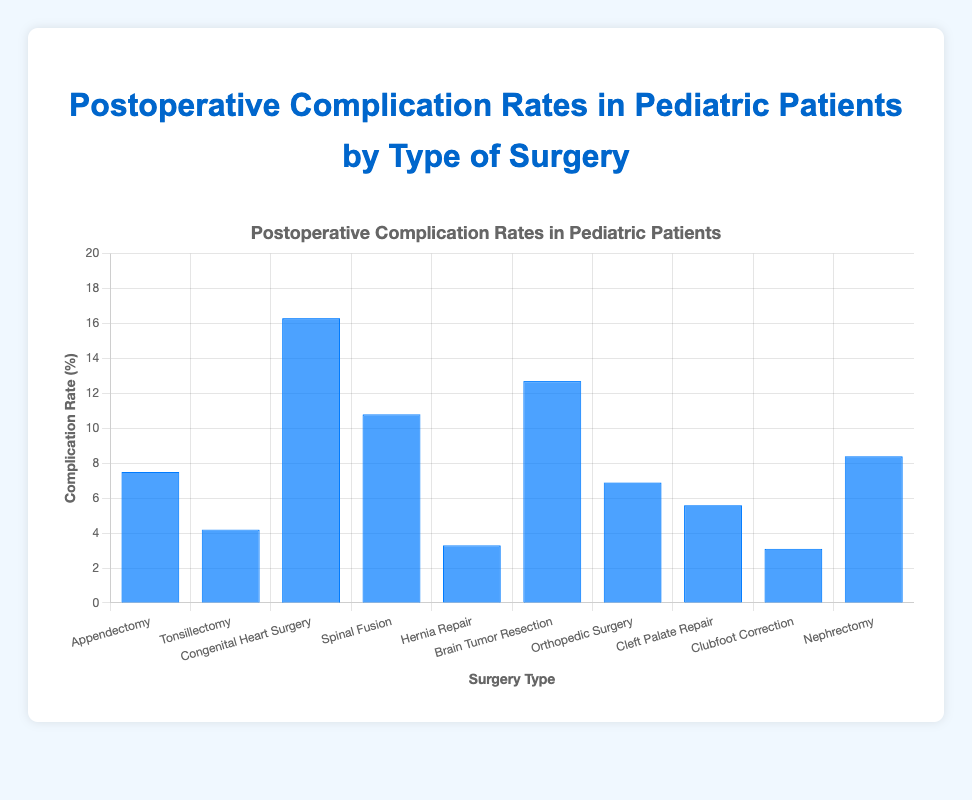What's the type of surgery with the highest postoperative complication rate? The highest postoperative complication rate is indicated by the tallest bar in the chart. The "Congenital Heart Surgery" bar is the tallest.
Answer: Congenital Heart Surgery Which type of surgery has a lower complication rate: Tonsillectomy or Orthopedic Surgery? The chart shows the complication rate for Tonsillectomy is 4.2% and for Orthopedic Surgery is 6.9%. Tonsillectomy has a lower rate.
Answer: Tonsillectomy What's the difference in complication rates between the surgery with the highest rate and the surgery with the lowest rate? Congenital Heart Surgery has the highest rate at 16.3%, and Clubfoot Correction has the lowest rate at 3.1%. The difference is 16.3% - 3.1% = 13.2%.
Answer: 13.2% How many types of surgeries have complication rates higher than 10%? Count the bars that extend above the 10% mark. These are Congenital Heart Surgery, Spinal Fusion, and Brain Tumor Resection.
Answer: 3 What’s the average complication rate for Appendectomy, Tonsillectomy, and Nephrectomy combined? Sum the complication rates for Appendectomy (7.5%), Tonsillectomy (4.2%), and Nephrectomy (8.4%), then divide by 3. (7.5 + 4.2 + 8.4) / 3 = 6.7%.
Answer: 6.7% Which type of surgery has a complication rate closest to the overall average complication rate of all surgeries listed? Calculate the overall average: (7.5 + 4.2 + 16.3 + 10.8 + 3.3 + 12.7 + 6.9 + 5.6 + 3.1 + 8.4) / 10 = 7.88%. Appendectomy (7.5%) is the closest.
Answer: Appendectomy Rank the types of surgeries from highest to lowest complication rates. List the complication rates in descending order: Congenital Heart Surgery (16.3%), Brain Tumor Resection (12.7%), Spinal Fusion (10.8%), Nephrectomy (8.4%), Appendectomy (7.5%), Orthopedic Surgery (6.9%), Cleft Palate Repair (5.6%), Tonsillectomy (4.2%), Hernia Repair (3.3%), Clubfoot Correction (3.1%).
Answer: Congenital Heart Surgery, Brain Tumor Resection, Spinal Fusion, Nephrectomy, Appendectomy, Orthopedic Surgery, Cleft Palate Repair, Tonsillectomy, Hernia Repair, Clubfoot Correction What’s the sum of the complication rates for all surgeries with rates less than 5%? Identify and sum the rates: Tonsillectomy (4.2%), Hernia Repair (3.3%), Clubfoot Correction (3.1%). 4.2 + 3.3 + 3.1 = 10.6%.
Answer: 10.6% Between Appendectomy and Spinal Fusion, which surgery type has a higher complication rate and by how much? Appendectomy has 7.5%, and Spinal Fusion has 10.8%. The difference is 10.8% - 7.5% = 3.3%.
Answer: Spinal Fusion, 3.3% What’s the complication rate for surgeries labeled in blue? All bars are labeled in blue. Therefore, all complication rates are considered: Appendectomy (7.5%), Tonsillectomy (4.2%), Congenital Heart Surgery (16.3%), Spinal Fusion (10.8%), Hernia Repair (3.3%), Brain Tumor Resection (12.7%), Orthopedic Surgery (6.9%), Cleft Palate Repair (5.6%), Clubfoot Correction (3.1%), Nephrectomy (8.4%).
Answer: 7.5%, 4.2%, 16.3%, 10.8%, 3.3%, 12.7%, 6.9%, 5.6%, 3.1%, 8.4% 